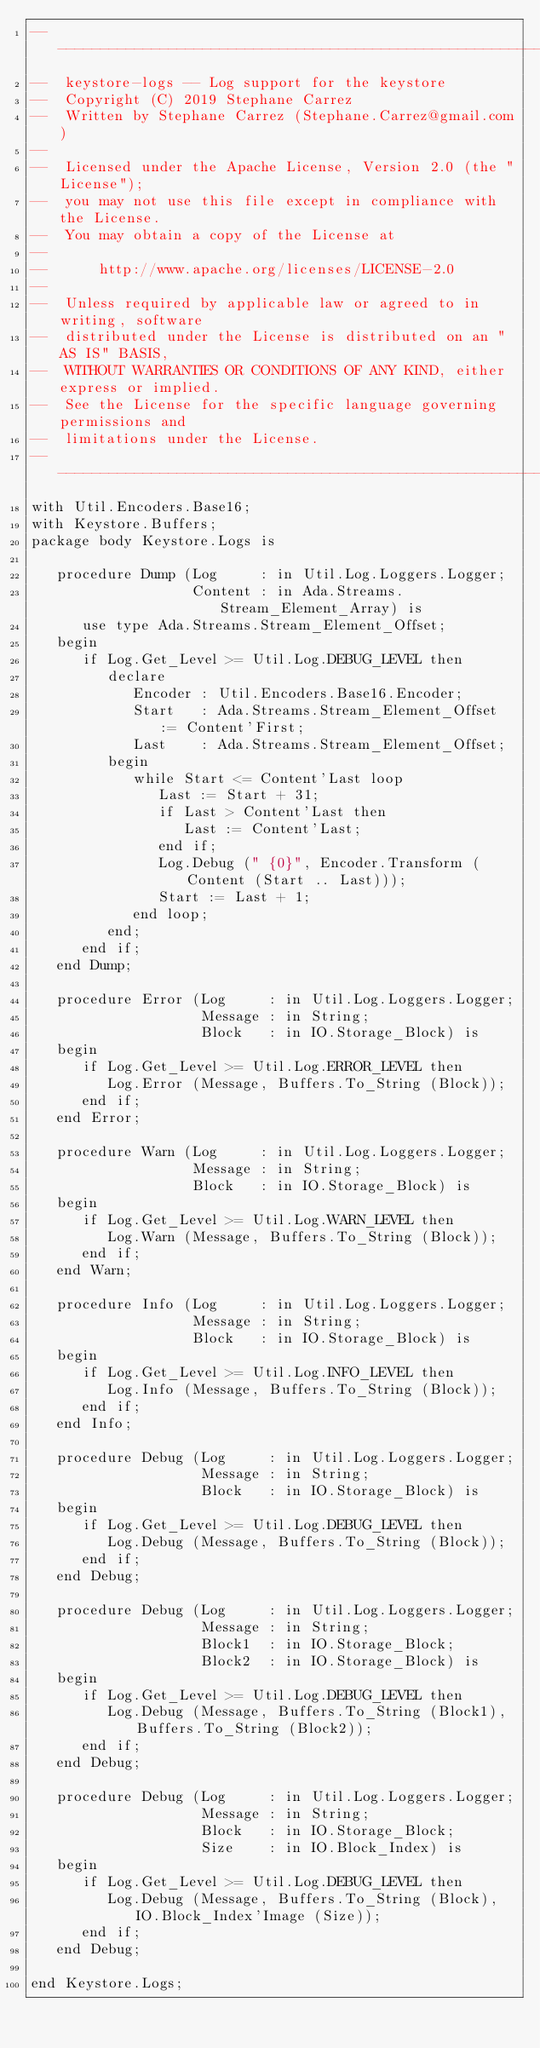<code> <loc_0><loc_0><loc_500><loc_500><_Ada_>-----------------------------------------------------------------------
--  keystore-logs -- Log support for the keystore
--  Copyright (C) 2019 Stephane Carrez
--  Written by Stephane Carrez (Stephane.Carrez@gmail.com)
--
--  Licensed under the Apache License, Version 2.0 (the "License");
--  you may not use this file except in compliance with the License.
--  You may obtain a copy of the License at
--
--      http://www.apache.org/licenses/LICENSE-2.0
--
--  Unless required by applicable law or agreed to in writing, software
--  distributed under the License is distributed on an "AS IS" BASIS,
--  WITHOUT WARRANTIES OR CONDITIONS OF ANY KIND, either express or implied.
--  See the License for the specific language governing permissions and
--  limitations under the License.
-----------------------------------------------------------------------
with Util.Encoders.Base16;
with Keystore.Buffers;
package body Keystore.Logs is

   procedure Dump (Log     : in Util.Log.Loggers.Logger;
                   Content : in Ada.Streams.Stream_Element_Array) is
      use type Ada.Streams.Stream_Element_Offset;
   begin
      if Log.Get_Level >= Util.Log.DEBUG_LEVEL then
         declare
            Encoder : Util.Encoders.Base16.Encoder;
            Start   : Ada.Streams.Stream_Element_Offset := Content'First;
            Last    : Ada.Streams.Stream_Element_Offset;
         begin
            while Start <= Content'Last loop
               Last := Start + 31;
               if Last > Content'Last then
                  Last := Content'Last;
               end if;
               Log.Debug (" {0}", Encoder.Transform (Content (Start .. Last)));
               Start := Last + 1;
            end loop;
         end;
      end if;
   end Dump;

   procedure Error (Log     : in Util.Log.Loggers.Logger;
                    Message : in String;
                    Block   : in IO.Storage_Block) is
   begin
      if Log.Get_Level >= Util.Log.ERROR_LEVEL then
         Log.Error (Message, Buffers.To_String (Block));
      end if;
   end Error;

   procedure Warn (Log     : in Util.Log.Loggers.Logger;
                   Message : in String;
                   Block   : in IO.Storage_Block) is
   begin
      if Log.Get_Level >= Util.Log.WARN_LEVEL then
         Log.Warn (Message, Buffers.To_String (Block));
      end if;
   end Warn;

   procedure Info (Log     : in Util.Log.Loggers.Logger;
                   Message : in String;
                   Block   : in IO.Storage_Block) is
   begin
      if Log.Get_Level >= Util.Log.INFO_LEVEL then
         Log.Info (Message, Buffers.To_String (Block));
      end if;
   end Info;

   procedure Debug (Log     : in Util.Log.Loggers.Logger;
                    Message : in String;
                    Block   : in IO.Storage_Block) is
   begin
      if Log.Get_Level >= Util.Log.DEBUG_LEVEL then
         Log.Debug (Message, Buffers.To_String (Block));
      end if;
   end Debug;

   procedure Debug (Log     : in Util.Log.Loggers.Logger;
                    Message : in String;
                    Block1  : in IO.Storage_Block;
                    Block2  : in IO.Storage_Block) is
   begin
      if Log.Get_Level >= Util.Log.DEBUG_LEVEL then
         Log.Debug (Message, Buffers.To_String (Block1), Buffers.To_String (Block2));
      end if;
   end Debug;

   procedure Debug (Log     : in Util.Log.Loggers.Logger;
                    Message : in String;
                    Block   : in IO.Storage_Block;
                    Size    : in IO.Block_Index) is
   begin
      if Log.Get_Level >= Util.Log.DEBUG_LEVEL then
         Log.Debug (Message, Buffers.To_String (Block), IO.Block_Index'Image (Size));
      end if;
   end Debug;

end Keystore.Logs;
</code> 